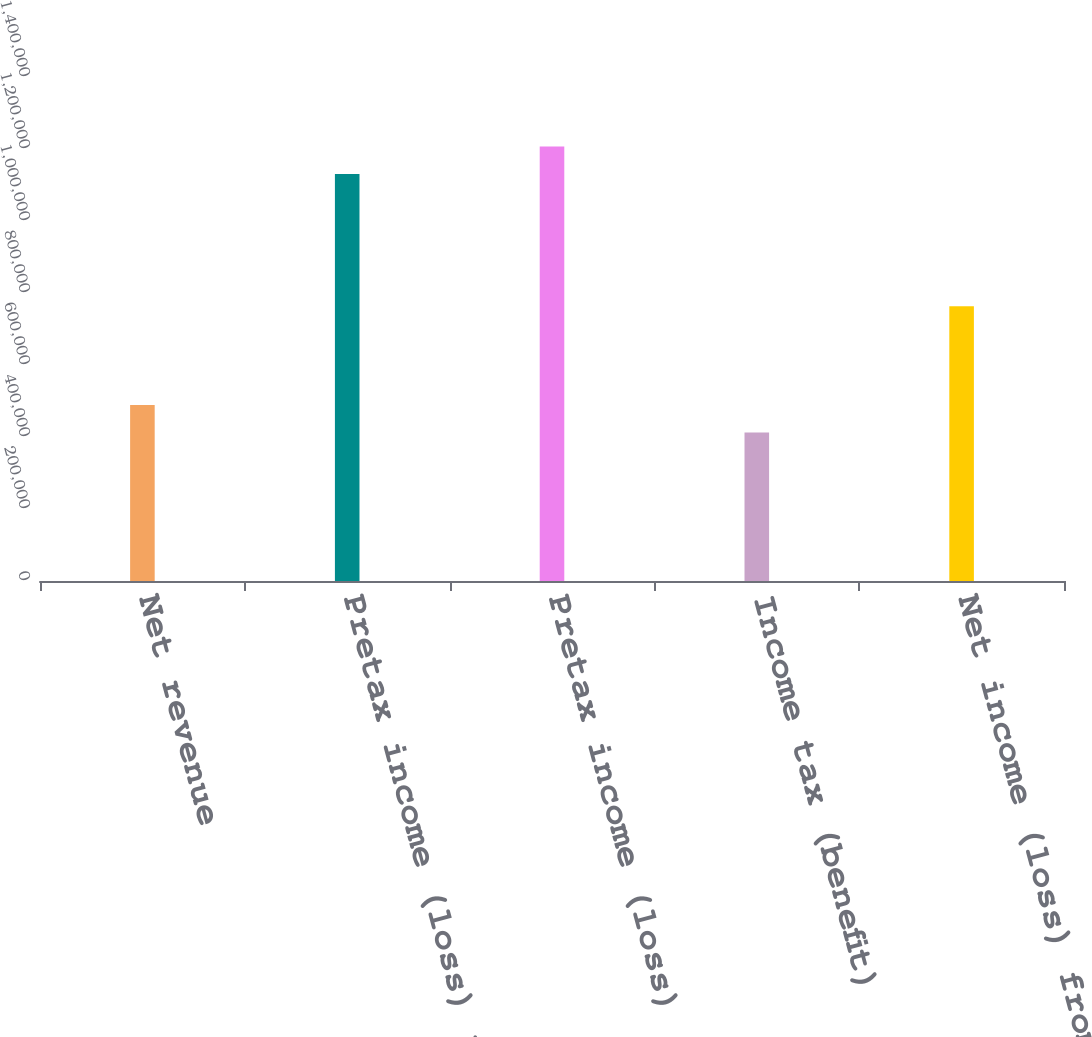<chart> <loc_0><loc_0><loc_500><loc_500><bar_chart><fcel>Net revenue<fcel>Pretax income (loss) from<fcel>Pretax income (loss)<fcel>Income tax (benefit)<fcel>Net income (loss) from<nl><fcel>489065<fcel>1.13037e+06<fcel>1.20668e+06<fcel>412753<fcel>763123<nl></chart> 